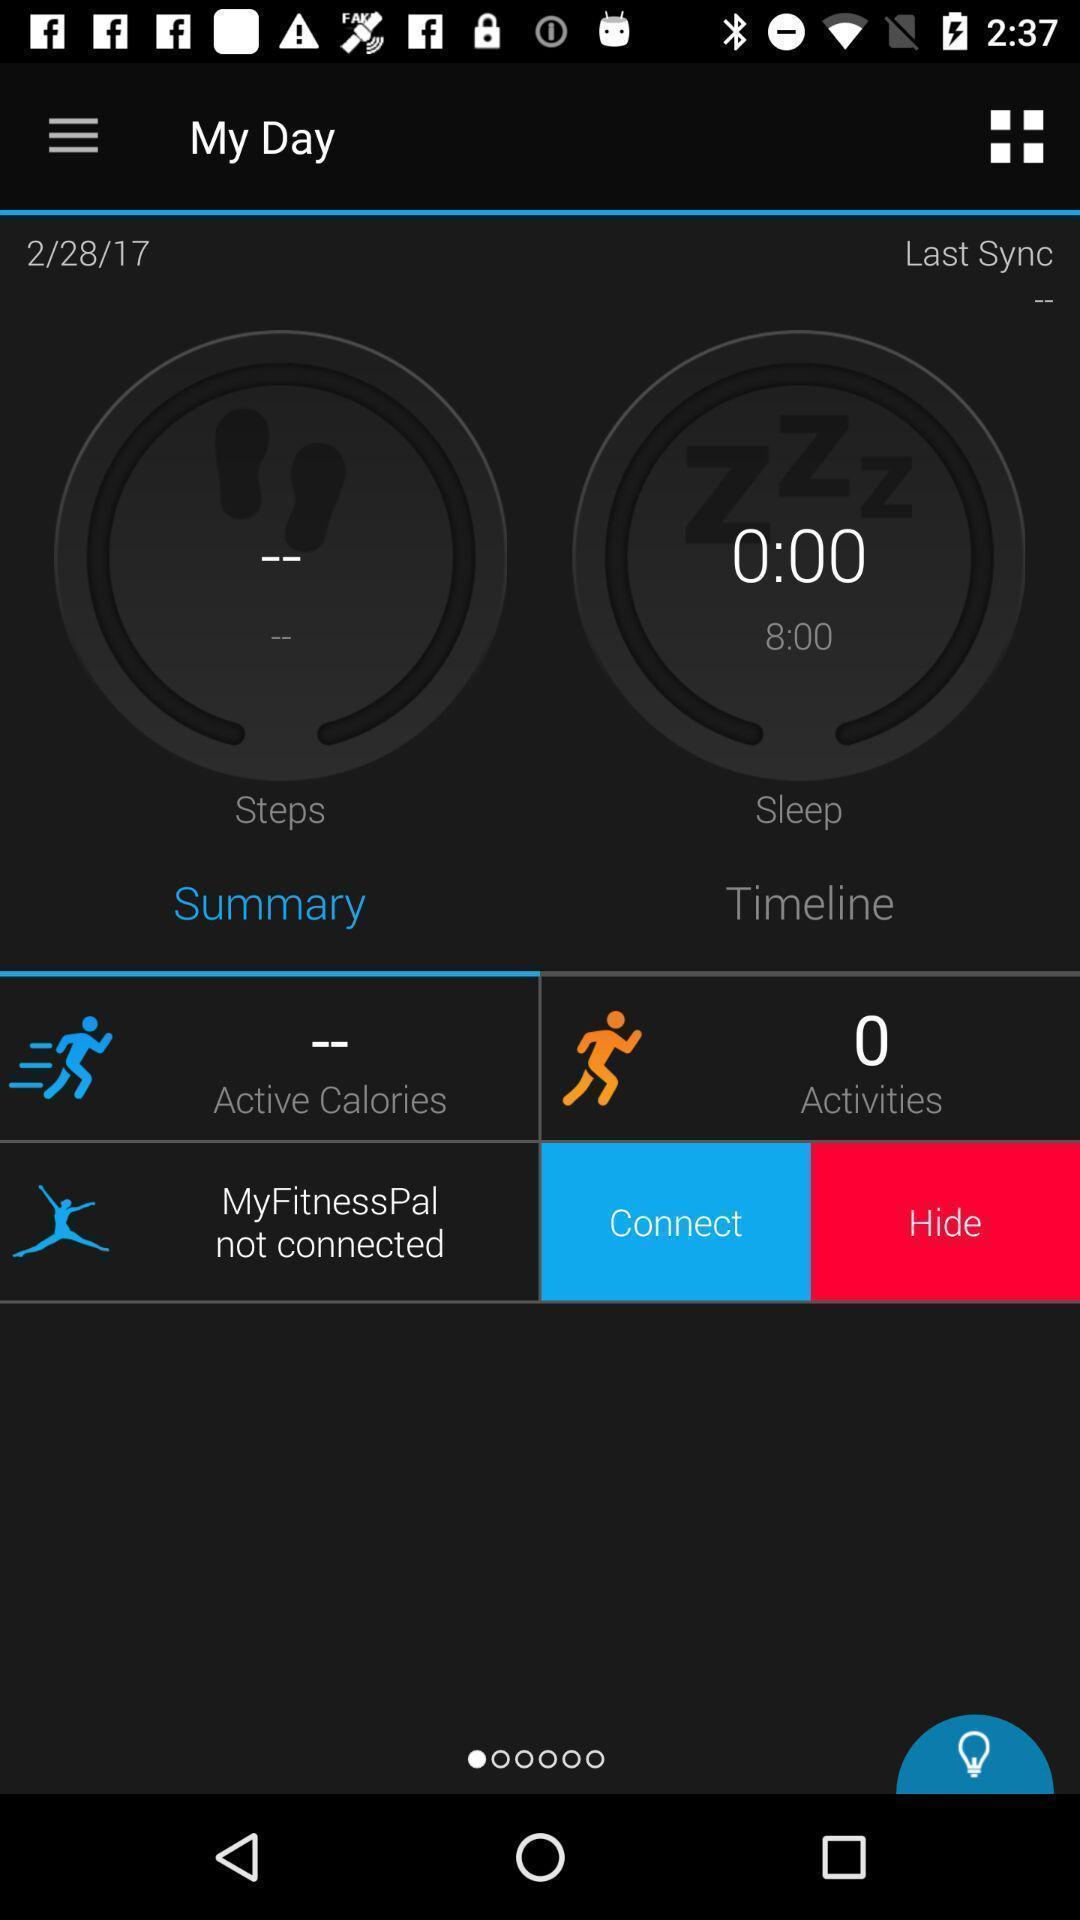What can you discern from this picture? Page showing different parameters on a fitness tracking app. 